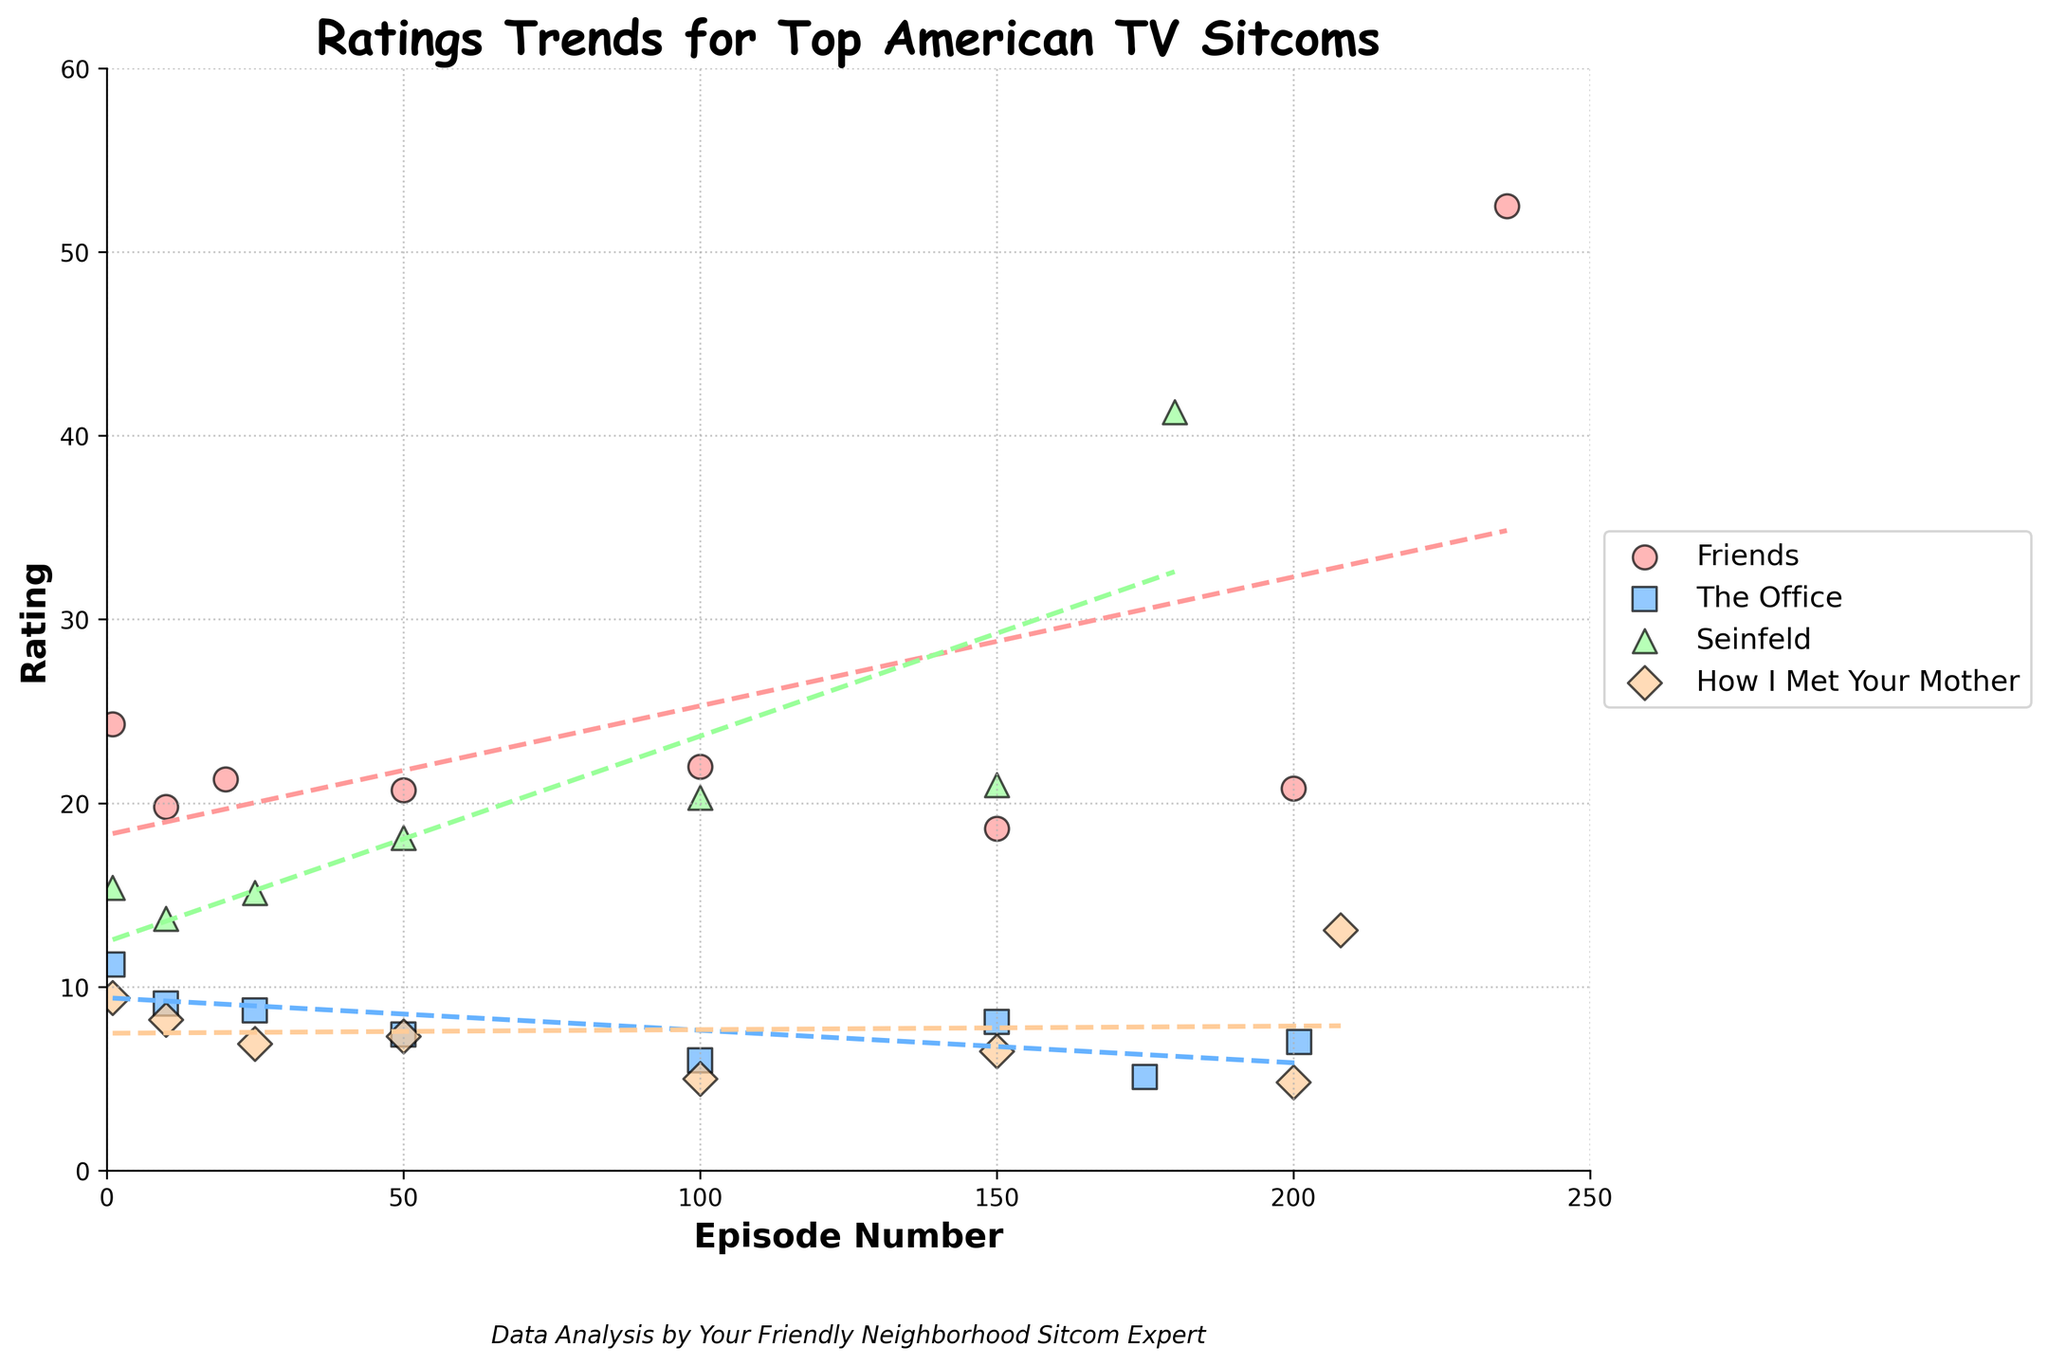What is the title of the figure? The title of the figure is usually clearly visible at the top of the chart. In this figure, it is written in bold font, making it easy to identify.
Answer: Ratings Trends for Top American TV Sitcoms Which show had the highest rating for its final episode? The highest ratings for finale episodes can be identified by looking at the ratings manually, and the conclusion can be verified by inspecting the plot. "Friends" has a sharp peak near the end of its line.
Answer: Friends How does the ratings trend for Seinfeld compare to The Office? By looking at the scatter plot and the trend lines for both shows, you can see that Seinfeld's ratings generally increased, while The Office's ratings decreased over time.
Answer: Seinfeld's ratings trend upward, while The Office's trend downward What is the general trend of ratings for How I Met Your Mother? The trend line for How I Met Your Mother shows a general decline over the span of the episodes, indicating that ratings decreased over time.
Answer: Declining How many unique TV shows are represented in the figure? The number of unique TV shows can be determined by counting the different categories in the legend. There are four unique shows listed.
Answer: 4 Which show has the steepest upward trend in its ratings over time? The steepness of the trend lines can be observed. The steepest increasing trend belongs to Friends, as its trend line rises sharply.
Answer: Friends Which TV show had a final episode with a rating above 40? This can be verified by examining the ratings near the end of each trend line. "Seinfeld" and "Friends" show final episodes with ratings above 40.
Answer: Seinfeld Which show has the least variation in its ratings throughout its run? Least variation can be identified by looking at the scatter points' spread for each show. The Office shows the least variation with closely grouped ratings.
Answer: The Office Do all shows have a clear trend line in the scatter plot? Checking if every dataset has a corresponding trend line in the plot answers this. All shows do have trend lines.
Answer: Yes Which show's trend line stays consistently above 10 for most of its episodes? Observing the trend lines and their positions in relation to the y-axis values throughout the episodes. Seinfeld’s trend line stays above 10 for most of its run.
Answer: Seinfeld 